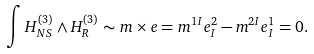<formula> <loc_0><loc_0><loc_500><loc_500>\int H _ { N S } ^ { ( 3 ) } \wedge H _ { R } ^ { ( 3 ) } \sim m \times e = m ^ { 1 I } e _ { I } ^ { 2 } - m ^ { 2 I } e _ { I } ^ { 1 } = 0 .</formula> 